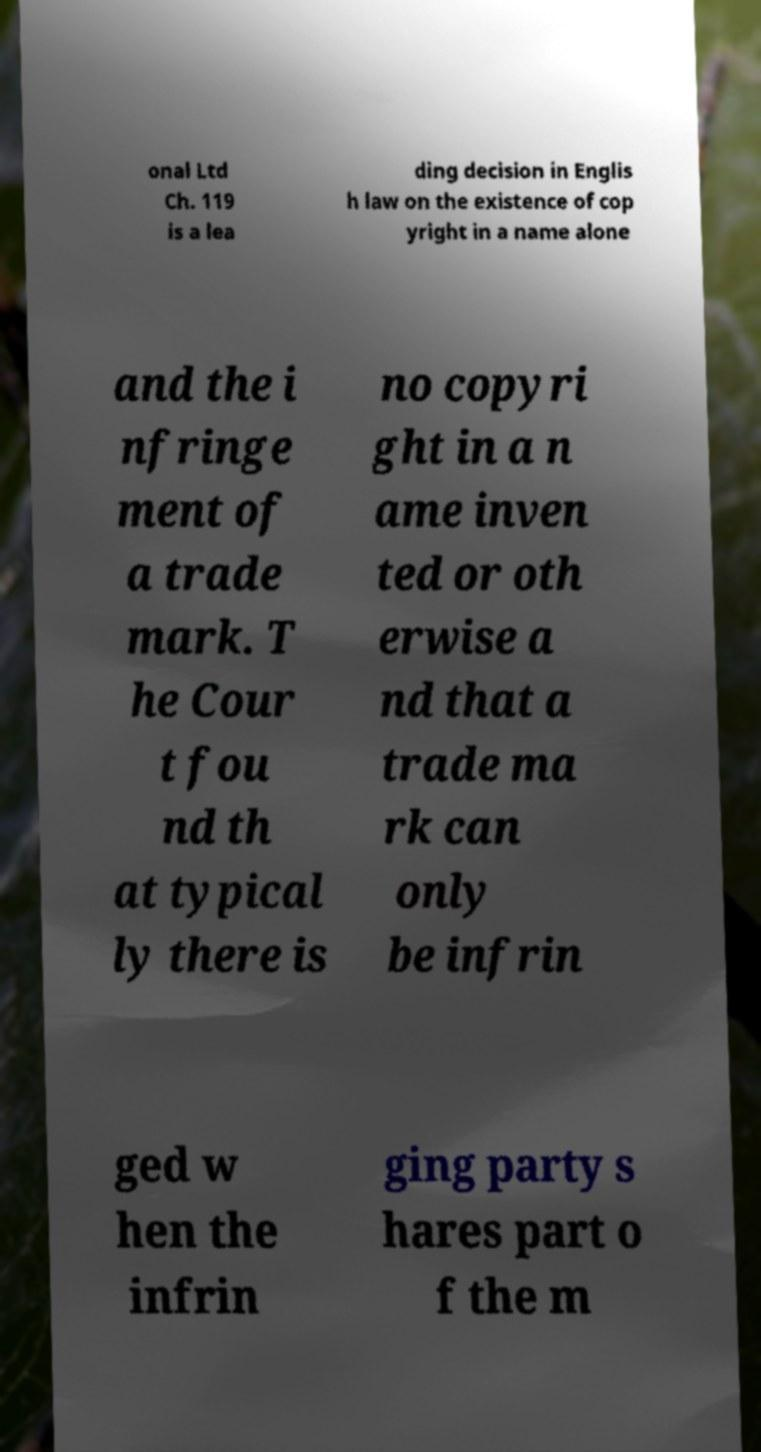What messages or text are displayed in this image? I need them in a readable, typed format. onal Ltd Ch. 119 is a lea ding decision in Englis h law on the existence of cop yright in a name alone and the i nfringe ment of a trade mark. T he Cour t fou nd th at typical ly there is no copyri ght in a n ame inven ted or oth erwise a nd that a trade ma rk can only be infrin ged w hen the infrin ging party s hares part o f the m 